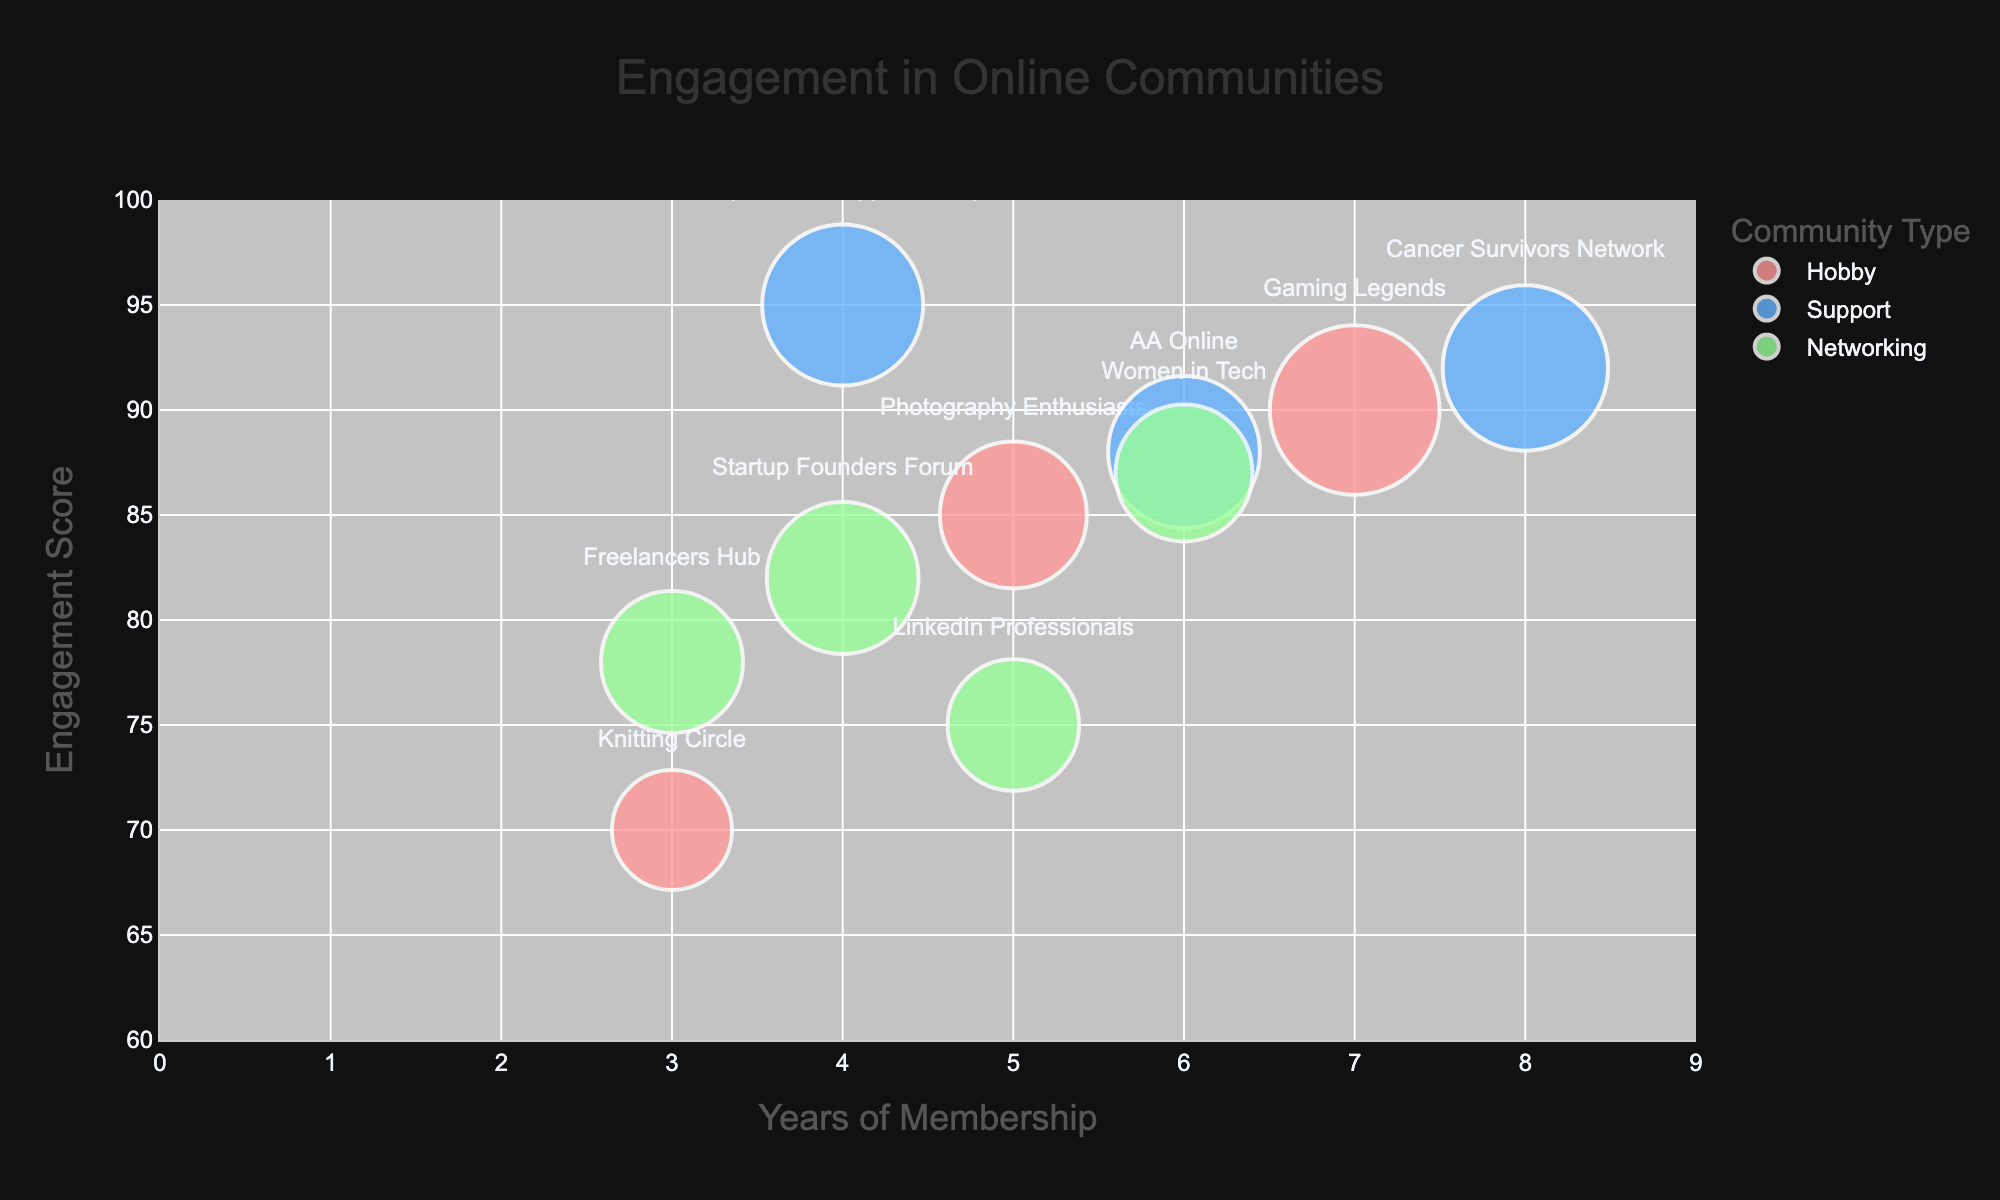what is the title of the chart? The title of the chart is visibly located at the top of the figure and is prominently displayed.
Answer: Engagement in Online Communities what is the engagement score of the "Freelancers Hub" community? Locate the "Freelancers Hub" community on the chart by hovering over or reading the labels; the engagement score is indicated beside the bubble.
Answer: 78 Which type of community has the most data points? Count the number of data points for each community type by observing the color-coded bubbles in the chart. Support (blue) has the most data points with four communities.
Answer: Support What is the average engagement score for Networking communities? Networking communities have the following scores: 75, 78, 82, 87. The average is calculated as (75 + 78 + 82 + 87) / 4 = 80.5.
Answer: 80.5 Which community has the largest bubble on the chart? Identify the bubble with the largest size on the chart, usually located either by hovering over or observing the visually largest bubble. The largest bubble is associated with the "Gaming Legends" community, which has a bubble size of 200.
Answer: Gaming Legends How does the range of years of membership extend in the chart? Observe the x-axis to determine the minimum and maximum values of years of membership. The range is from 0 to 9 years.
Answer: 0 to 9 years What is the difference in engagement scores between "Gaming Legends" and "AA Online"? Locate the engagement scores of both communities on the chart: "Gaming Legends" is 90 and "AA Online" is 88. The difference is calculated as 90 - 88 = 2.
Answer: 2 Which community has a higher engagement score: "Women in Tech" or "Knitting Circle"? Compare the engagement scores of "Women in Tech" and "Knitting Circle" by locating their points on the chart. "Women in Tech" has an engagement score of 87, while "Knitting Circle" has 70. "Women in Tech" has the higher score.
Answer: Women in Tech What is the relationship between years of membership and engagement score for Support communities? Examine the distribution of bubbles for Support (blue) across the x-axis (years of membership) and y-axis (engagement score) to see if there's any visible trend. Generally, as years of membership increase, the engagement score in Support communities remains high, indicating a strong positive engagement.
Answer: High engagement scores with increasing years of membership Which type of community has the highest average number of years of membership? Calculate the average years of membership for each community type by summing their years and dividing by the number of communities, then compare these averages. For Hobby: (5+3+7)/3 = 5; for Support: (4+6+8)/4 = 4.5; for Networking: (5+3+4+6)/4 = 4.5. "Hobby" has the highest average.
Answer: Hobby 